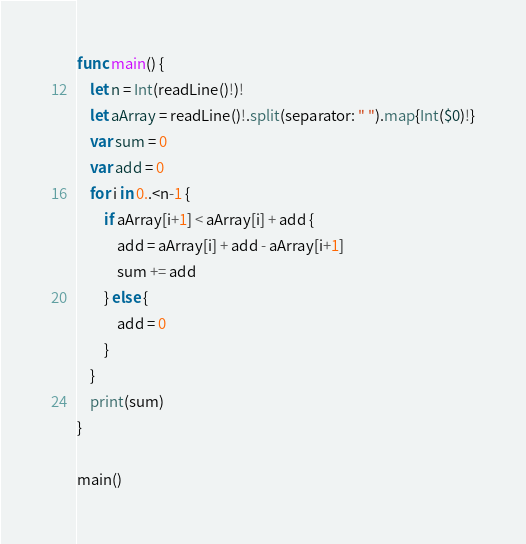<code> <loc_0><loc_0><loc_500><loc_500><_Swift_>func main() {
    let n = Int(readLine()!)!
    let aArray = readLine()!.split(separator: " ").map{Int($0)!}
    var sum = 0
    var add = 0
    for i in 0..<n-1 {
        if aArray[i+1] < aArray[i] + add {
            add = aArray[i] + add - aArray[i+1]
            sum += add
        } else {
            add = 0
        }
    }
    print(sum)
}

main()</code> 